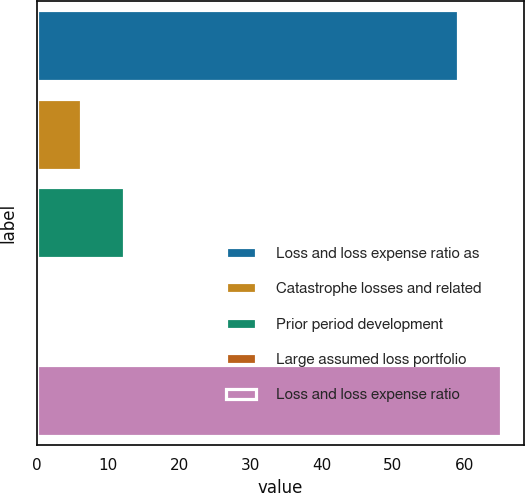Convert chart to OTSL. <chart><loc_0><loc_0><loc_500><loc_500><bar_chart><fcel>Loss and loss expense ratio as<fcel>Catastrophe losses and related<fcel>Prior period development<fcel>Large assumed loss portfolio<fcel>Loss and loss expense ratio<nl><fcel>59.2<fcel>6.3<fcel>12.3<fcel>0.3<fcel>65.2<nl></chart> 